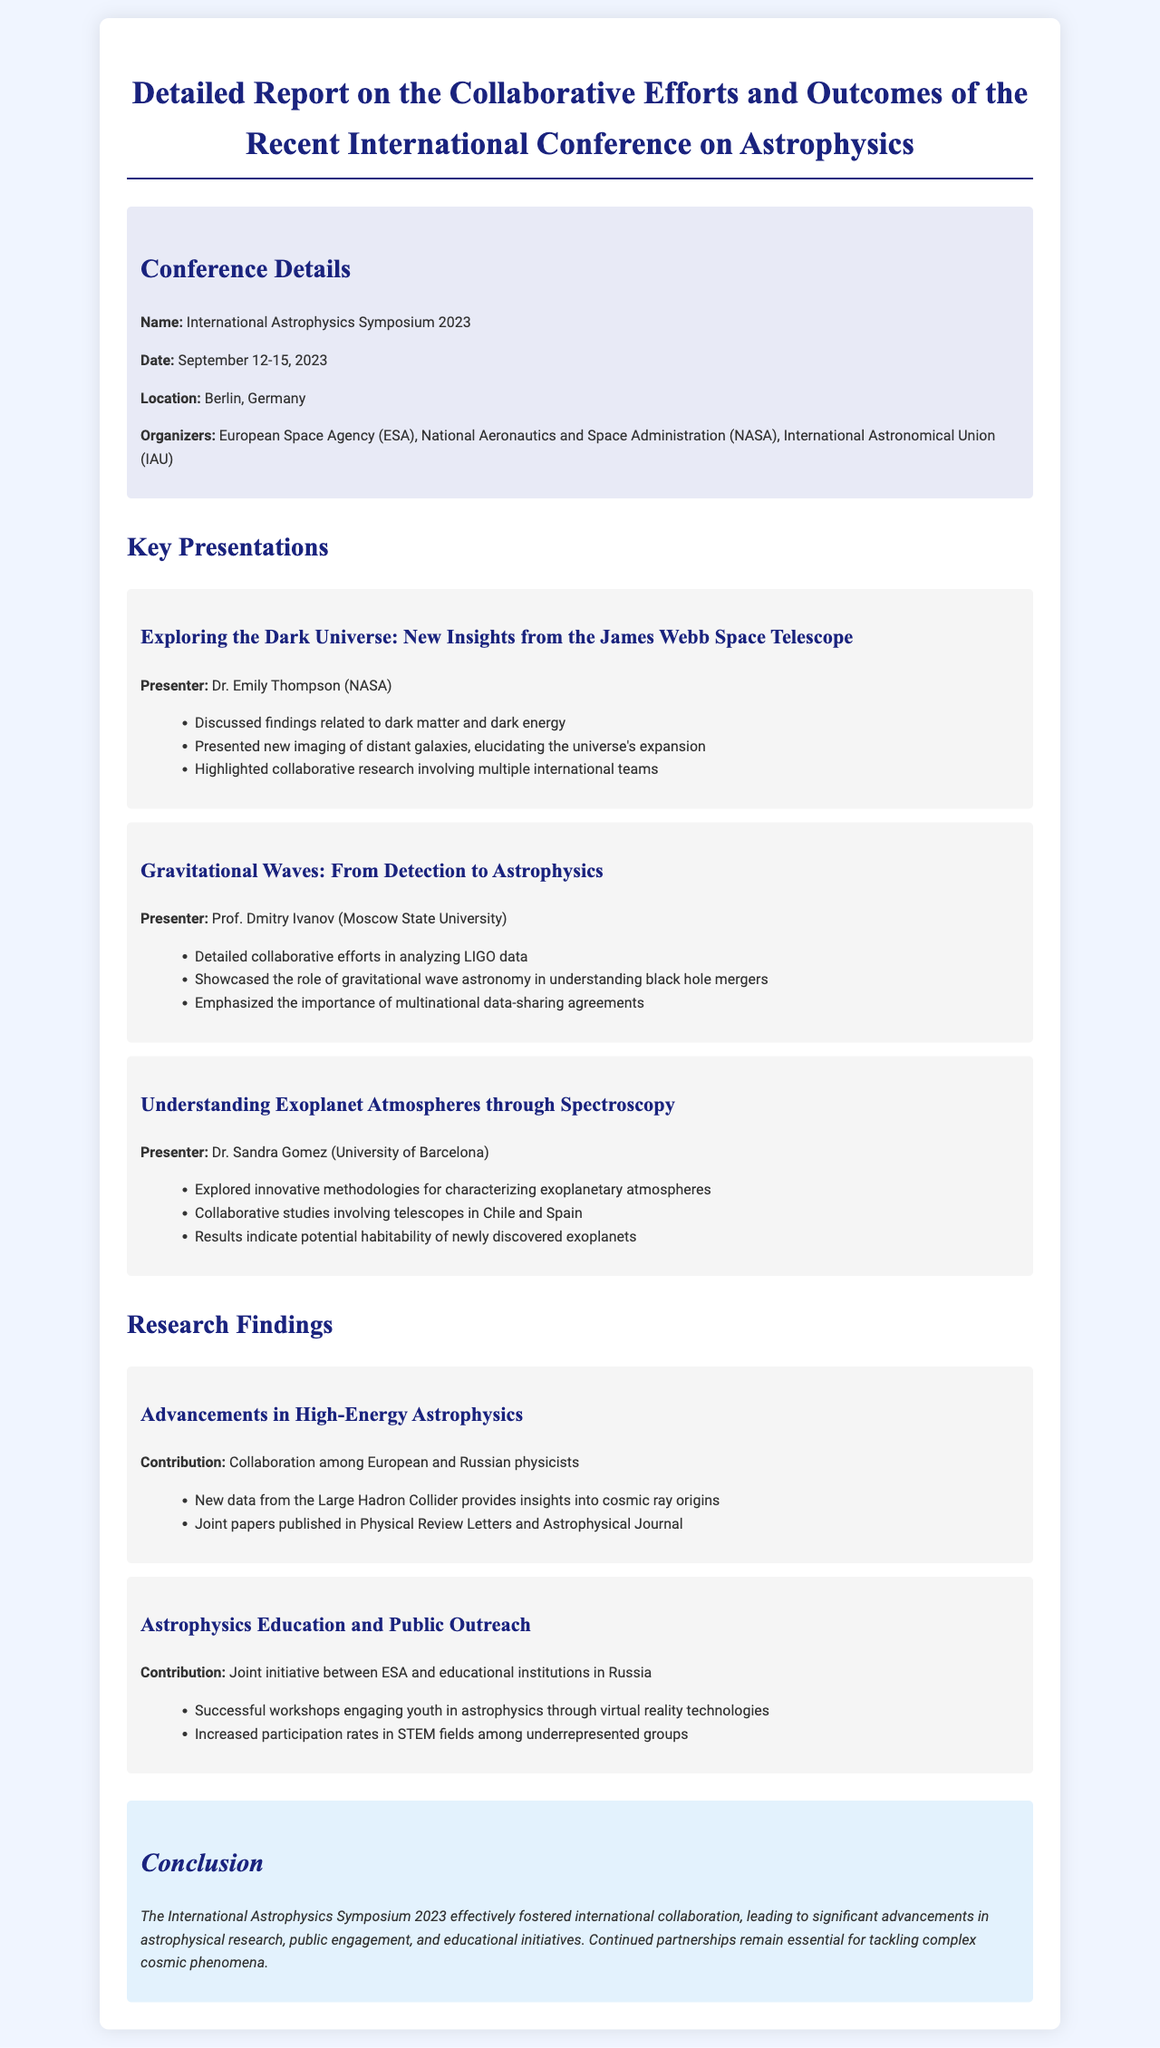What is the name of the conference? The name of the conference is mentioned in the document under the conference details section.
Answer: International Astrophysics Symposium 2023 Who presented on gravitational waves? The document lists the presenters for each presentation, highlighting their focus areas.
Answer: Prof. Dmitry Ivanov What dates did the conference occur? The dates are specified in the conference details section of the document.
Answer: September 12-15, 2023 Which organization is one of the conference organizers? Organizations responsible for organizing the conference are listed in the details section.
Answer: European Space Agency (ESA) What significant topic was discussed by Dr. Emily Thompson? The presentations summarize key findings and insights by the presenters.
Answer: Dark matter and dark energy How many presentations are mentioned in the report? The document details a specific number of key presentations given during the conference.
Answer: Three presentations What type of initiative was highlighted regarding education and public outreach? The findings section discusses contributions and initiatives related to education.
Answer: Joint initiative What was the location of the conference? The document states the geographical location where the conference took place.
Answer: Berlin, Germany What is an outcome of the collaboration among European and Russian physicists? The research findings detail significant outcomes from collaborations.
Answer: Insights into cosmic ray origins 